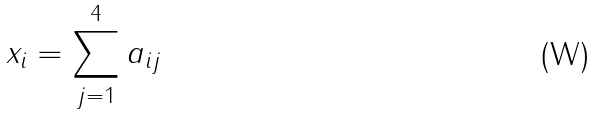<formula> <loc_0><loc_0><loc_500><loc_500>x _ { i } = \sum _ { j = 1 } ^ { 4 } a _ { i j }</formula> 